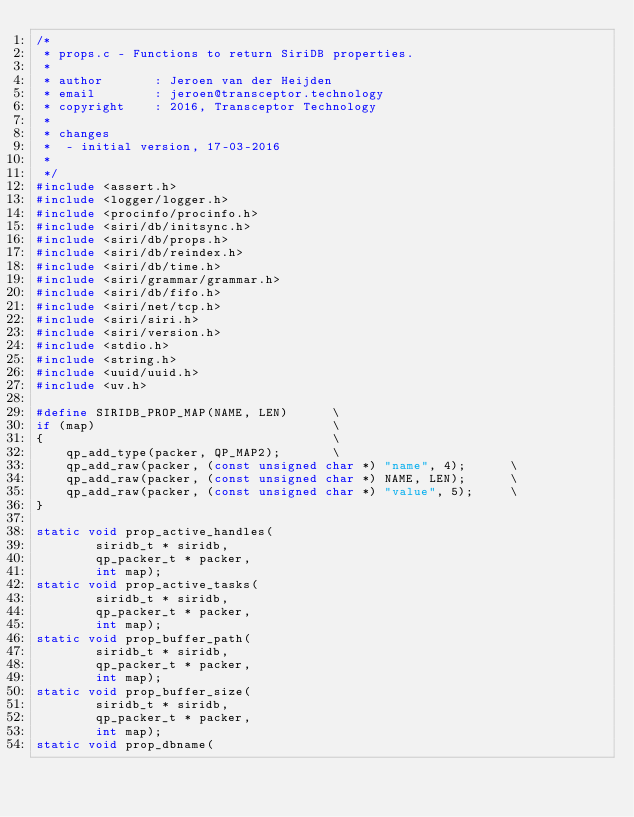Convert code to text. <code><loc_0><loc_0><loc_500><loc_500><_C_>/*
 * props.c - Functions to return SiriDB properties.
 *
 * author       : Jeroen van der Heijden
 * email        : jeroen@transceptor.technology
 * copyright    : 2016, Transceptor Technology
 *
 * changes
 *  - initial version, 17-03-2016
 *
 */
#include <assert.h>
#include <logger/logger.h>
#include <procinfo/procinfo.h>
#include <siri/db/initsync.h>
#include <siri/db/props.h>
#include <siri/db/reindex.h>
#include <siri/db/time.h>
#include <siri/grammar/grammar.h>
#include <siri/db/fifo.h>
#include <siri/net/tcp.h>
#include <siri/siri.h>
#include <siri/version.h>
#include <stdio.h>
#include <string.h>
#include <uuid/uuid.h>
#include <uv.h>

#define SIRIDB_PROP_MAP(NAME, LEN)      \
if (map)                                \
{                                       \
    qp_add_type(packer, QP_MAP2);       \
    qp_add_raw(packer, (const unsigned char *) "name", 4);      \
    qp_add_raw(packer, (const unsigned char *) NAME, LEN);      \
    qp_add_raw(packer, (const unsigned char *) "value", 5);     \
}

static void prop_active_handles(
        siridb_t * siridb,
        qp_packer_t * packer,
        int map);
static void prop_active_tasks(
        siridb_t * siridb,
        qp_packer_t * packer,
        int map);
static void prop_buffer_path(
        siridb_t * siridb,
        qp_packer_t * packer,
        int map);
static void prop_buffer_size(
        siridb_t * siridb,
        qp_packer_t * packer,
        int map);
static void prop_dbname(</code> 